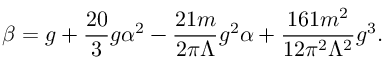Convert formula to latex. <formula><loc_0><loc_0><loc_500><loc_500>\beta = g + \frac { 2 0 } { 3 } g \alpha ^ { 2 } - \frac { 2 1 m } { 2 \pi \Lambda } g ^ { 2 } \alpha + \frac { 1 6 1 m ^ { 2 } } { 1 2 \pi ^ { 2 } \Lambda ^ { 2 } } g ^ { 3 } .</formula> 